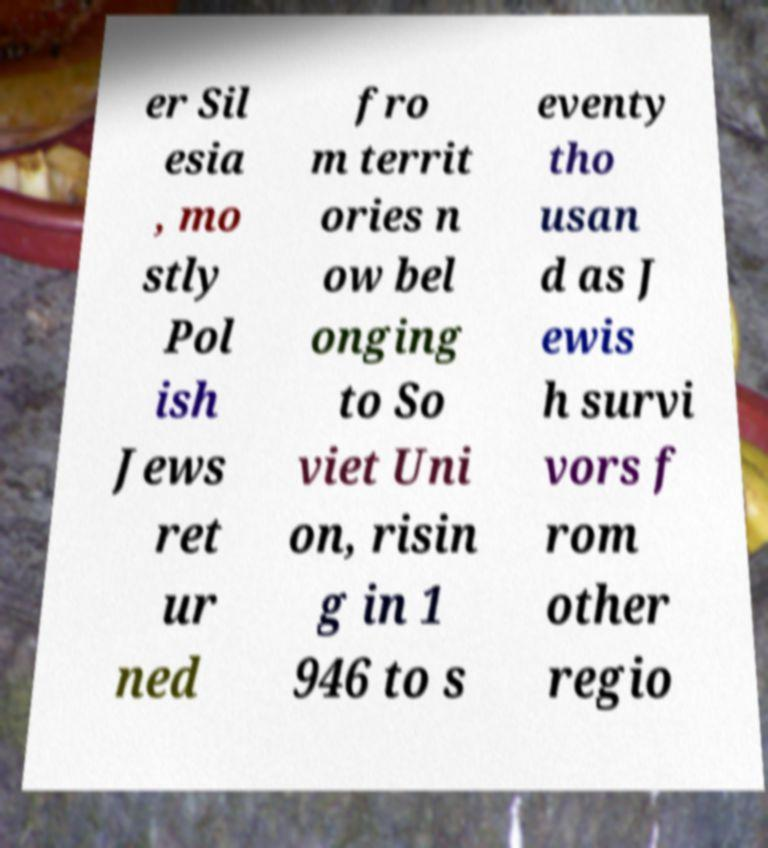Can you accurately transcribe the text from the provided image for me? er Sil esia , mo stly Pol ish Jews ret ur ned fro m territ ories n ow bel onging to So viet Uni on, risin g in 1 946 to s eventy tho usan d as J ewis h survi vors f rom other regio 